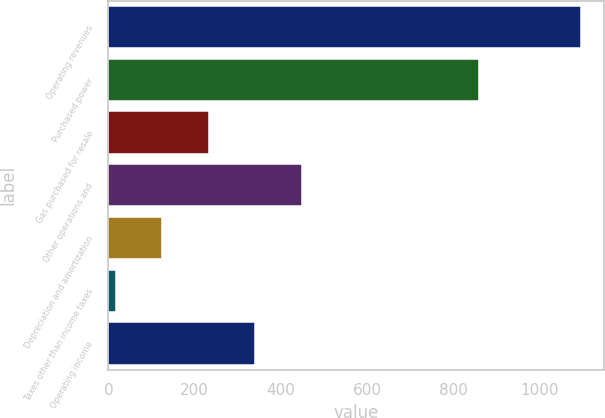Convert chart. <chart><loc_0><loc_0><loc_500><loc_500><bar_chart><fcel>Operating revenues<fcel>Purchased power<fcel>Gas purchased for resale<fcel>Other operations and<fcel>Depreciation and amortization<fcel>Taxes other than income taxes<fcel>Operating income<nl><fcel>1096<fcel>861<fcel>232.8<fcel>448.6<fcel>124.9<fcel>17<fcel>340.7<nl></chart> 